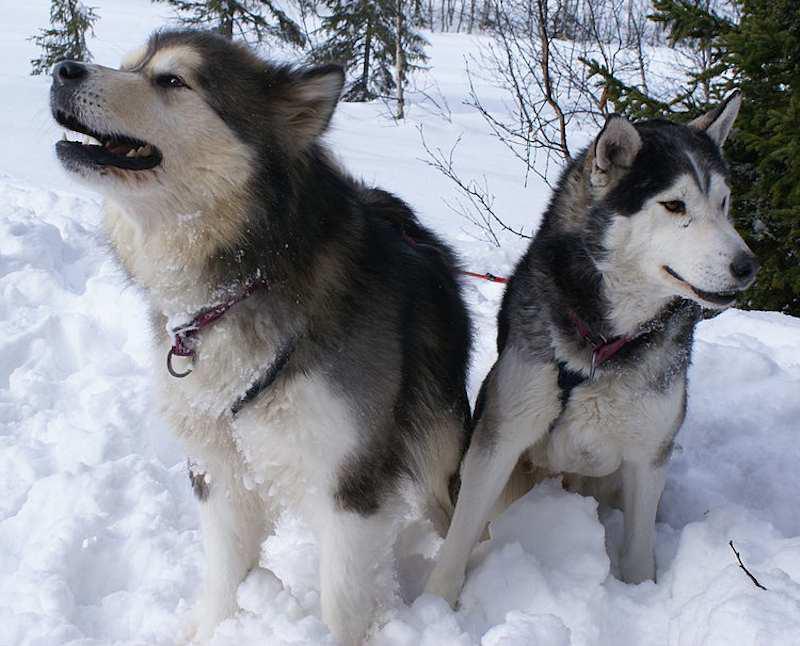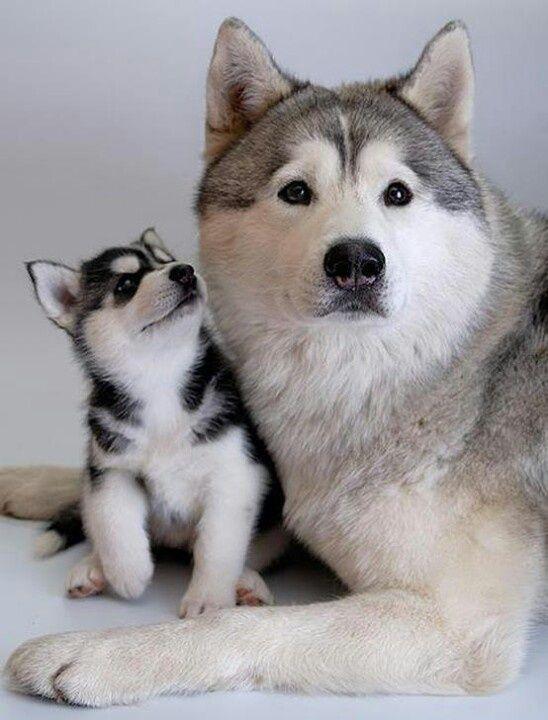The first image is the image on the left, the second image is the image on the right. Given the left and right images, does the statement "In at least one image there are two dogs and at least one is a very young husky puppy." hold true? Answer yes or no. Yes. The first image is the image on the left, the second image is the image on the right. Evaluate the accuracy of this statement regarding the images: "The left image features two huskies side by side, with at least one sitting upright, and the right image contains two dogs, with at least one reclining.". Is it true? Answer yes or no. Yes. 